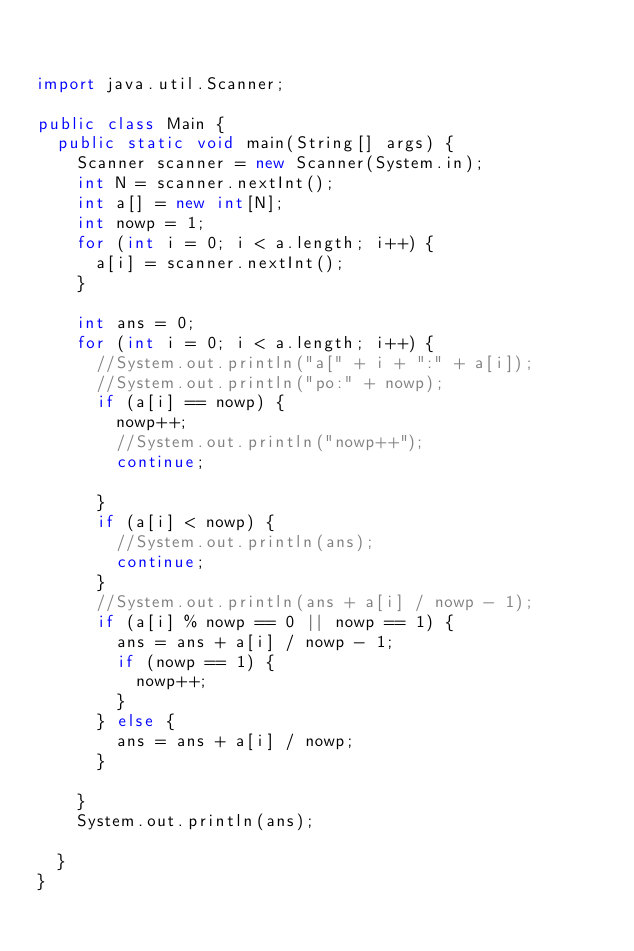Convert code to text. <code><loc_0><loc_0><loc_500><loc_500><_Java_>

import java.util.Scanner;

public class Main {
	public static void main(String[] args) {
		Scanner scanner = new Scanner(System.in);
		int N = scanner.nextInt();
		int a[] = new int[N];
		int nowp = 1;
		for (int i = 0; i < a.length; i++) {
			a[i] = scanner.nextInt();
		}

		int ans = 0;
		for (int i = 0; i < a.length; i++) {
			//System.out.println("a[" + i + ":" + a[i]);
			//System.out.println("po:" + nowp);
			if (a[i] == nowp) {
				nowp++;
				//System.out.println("nowp++");
				continue;

			}
			if (a[i] < nowp) {
				//System.out.println(ans);
				continue;
			}
			//System.out.println(ans + a[i] / nowp - 1);
			if (a[i] % nowp == 0 || nowp == 1) {
				ans = ans + a[i] / nowp - 1;
				if (nowp == 1) {
					nowp++;
				}
			} else {
				ans = ans + a[i] / nowp;
			}

		}
		System.out.println(ans);

	}
}
</code> 